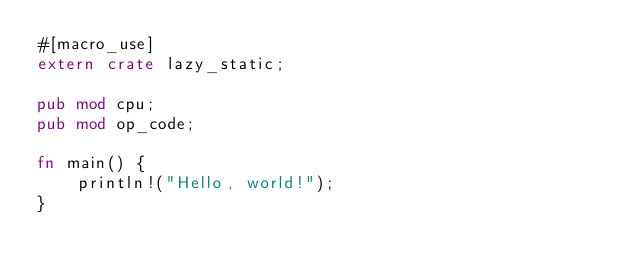Convert code to text. <code><loc_0><loc_0><loc_500><loc_500><_Rust_>#[macro_use]
extern crate lazy_static;

pub mod cpu;
pub mod op_code;

fn main() {
    println!("Hello, world!");
}
</code> 